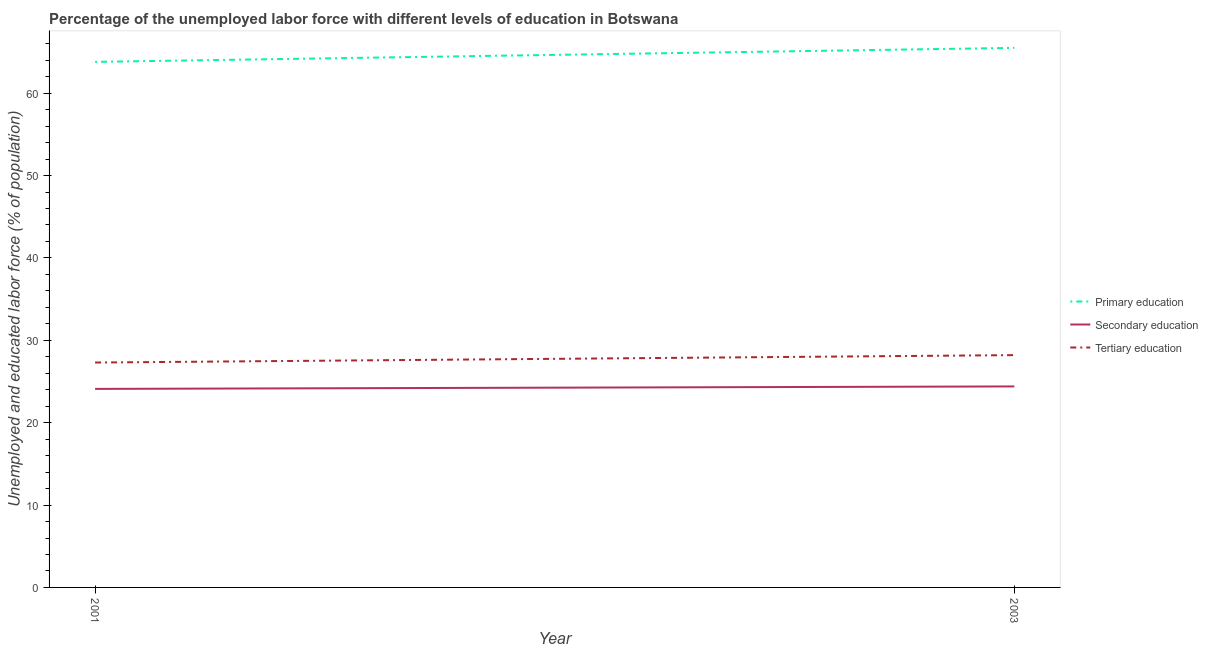How many different coloured lines are there?
Offer a terse response. 3. Is the number of lines equal to the number of legend labels?
Your answer should be very brief. Yes. What is the percentage of labor force who received tertiary education in 2001?
Make the answer very short. 27.3. Across all years, what is the maximum percentage of labor force who received secondary education?
Your answer should be compact. 24.4. Across all years, what is the minimum percentage of labor force who received primary education?
Make the answer very short. 63.8. What is the total percentage of labor force who received primary education in the graph?
Give a very brief answer. 129.3. What is the difference between the percentage of labor force who received secondary education in 2001 and that in 2003?
Make the answer very short. -0.3. What is the difference between the percentage of labor force who received primary education in 2001 and the percentage of labor force who received tertiary education in 2003?
Provide a succinct answer. 35.6. What is the average percentage of labor force who received primary education per year?
Your response must be concise. 64.65. In the year 2003, what is the difference between the percentage of labor force who received primary education and percentage of labor force who received secondary education?
Provide a succinct answer. 41.1. What is the ratio of the percentage of labor force who received tertiary education in 2001 to that in 2003?
Offer a very short reply. 0.97. Is the percentage of labor force who received primary education in 2001 less than that in 2003?
Offer a very short reply. Yes. In how many years, is the percentage of labor force who received tertiary education greater than the average percentage of labor force who received tertiary education taken over all years?
Give a very brief answer. 1. Is it the case that in every year, the sum of the percentage of labor force who received primary education and percentage of labor force who received secondary education is greater than the percentage of labor force who received tertiary education?
Your answer should be compact. Yes. Does the percentage of labor force who received secondary education monotonically increase over the years?
Provide a succinct answer. Yes. Is the percentage of labor force who received tertiary education strictly greater than the percentage of labor force who received primary education over the years?
Make the answer very short. No. Are the values on the major ticks of Y-axis written in scientific E-notation?
Ensure brevity in your answer.  No. How many legend labels are there?
Give a very brief answer. 3. What is the title of the graph?
Offer a very short reply. Percentage of the unemployed labor force with different levels of education in Botswana. Does "Industrial Nitrous Oxide" appear as one of the legend labels in the graph?
Provide a succinct answer. No. What is the label or title of the Y-axis?
Provide a succinct answer. Unemployed and educated labor force (% of population). What is the Unemployed and educated labor force (% of population) in Primary education in 2001?
Offer a very short reply. 63.8. What is the Unemployed and educated labor force (% of population) of Secondary education in 2001?
Make the answer very short. 24.1. What is the Unemployed and educated labor force (% of population) in Tertiary education in 2001?
Offer a terse response. 27.3. What is the Unemployed and educated labor force (% of population) of Primary education in 2003?
Keep it short and to the point. 65.5. What is the Unemployed and educated labor force (% of population) in Secondary education in 2003?
Your answer should be compact. 24.4. What is the Unemployed and educated labor force (% of population) of Tertiary education in 2003?
Give a very brief answer. 28.2. Across all years, what is the maximum Unemployed and educated labor force (% of population) in Primary education?
Provide a short and direct response. 65.5. Across all years, what is the maximum Unemployed and educated labor force (% of population) of Secondary education?
Provide a short and direct response. 24.4. Across all years, what is the maximum Unemployed and educated labor force (% of population) of Tertiary education?
Offer a very short reply. 28.2. Across all years, what is the minimum Unemployed and educated labor force (% of population) of Primary education?
Provide a short and direct response. 63.8. Across all years, what is the minimum Unemployed and educated labor force (% of population) in Secondary education?
Provide a succinct answer. 24.1. Across all years, what is the minimum Unemployed and educated labor force (% of population) in Tertiary education?
Provide a succinct answer. 27.3. What is the total Unemployed and educated labor force (% of population) of Primary education in the graph?
Make the answer very short. 129.3. What is the total Unemployed and educated labor force (% of population) of Secondary education in the graph?
Offer a very short reply. 48.5. What is the total Unemployed and educated labor force (% of population) in Tertiary education in the graph?
Make the answer very short. 55.5. What is the difference between the Unemployed and educated labor force (% of population) in Primary education in 2001 and that in 2003?
Your response must be concise. -1.7. What is the difference between the Unemployed and educated labor force (% of population) in Tertiary education in 2001 and that in 2003?
Your answer should be very brief. -0.9. What is the difference between the Unemployed and educated labor force (% of population) in Primary education in 2001 and the Unemployed and educated labor force (% of population) in Secondary education in 2003?
Give a very brief answer. 39.4. What is the difference between the Unemployed and educated labor force (% of population) in Primary education in 2001 and the Unemployed and educated labor force (% of population) in Tertiary education in 2003?
Keep it short and to the point. 35.6. What is the difference between the Unemployed and educated labor force (% of population) in Secondary education in 2001 and the Unemployed and educated labor force (% of population) in Tertiary education in 2003?
Ensure brevity in your answer.  -4.1. What is the average Unemployed and educated labor force (% of population) of Primary education per year?
Make the answer very short. 64.65. What is the average Unemployed and educated labor force (% of population) of Secondary education per year?
Your answer should be very brief. 24.25. What is the average Unemployed and educated labor force (% of population) in Tertiary education per year?
Your answer should be compact. 27.75. In the year 2001, what is the difference between the Unemployed and educated labor force (% of population) of Primary education and Unemployed and educated labor force (% of population) of Secondary education?
Give a very brief answer. 39.7. In the year 2001, what is the difference between the Unemployed and educated labor force (% of population) in Primary education and Unemployed and educated labor force (% of population) in Tertiary education?
Give a very brief answer. 36.5. In the year 2001, what is the difference between the Unemployed and educated labor force (% of population) in Secondary education and Unemployed and educated labor force (% of population) in Tertiary education?
Provide a succinct answer. -3.2. In the year 2003, what is the difference between the Unemployed and educated labor force (% of population) of Primary education and Unemployed and educated labor force (% of population) of Secondary education?
Your answer should be very brief. 41.1. In the year 2003, what is the difference between the Unemployed and educated labor force (% of population) of Primary education and Unemployed and educated labor force (% of population) of Tertiary education?
Your response must be concise. 37.3. What is the ratio of the Unemployed and educated labor force (% of population) of Primary education in 2001 to that in 2003?
Provide a short and direct response. 0.97. What is the ratio of the Unemployed and educated labor force (% of population) in Tertiary education in 2001 to that in 2003?
Provide a short and direct response. 0.97. What is the difference between the highest and the second highest Unemployed and educated labor force (% of population) of Primary education?
Keep it short and to the point. 1.7. What is the difference between the highest and the second highest Unemployed and educated labor force (% of population) of Secondary education?
Your response must be concise. 0.3. What is the difference between the highest and the lowest Unemployed and educated labor force (% of population) of Secondary education?
Provide a short and direct response. 0.3. 